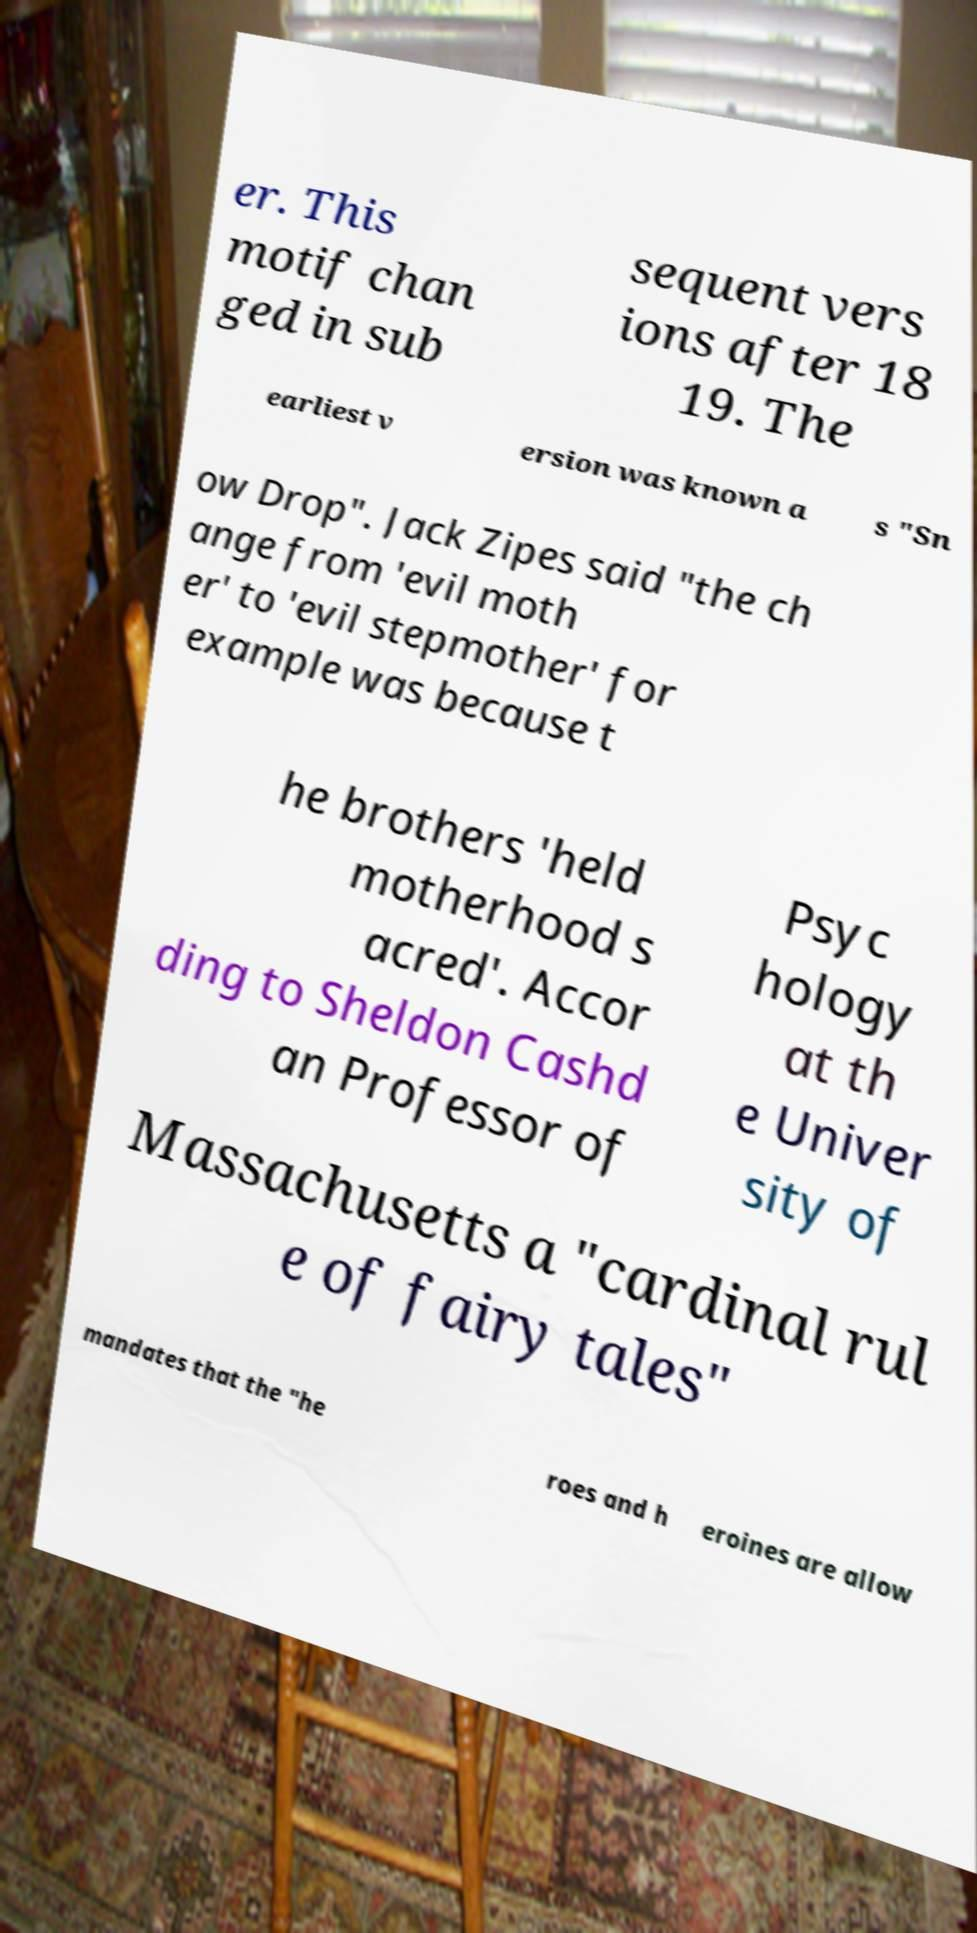I need the written content from this picture converted into text. Can you do that? er. This motif chan ged in sub sequent vers ions after 18 19. The earliest v ersion was known a s "Sn ow Drop". Jack Zipes said "the ch ange from 'evil moth er' to 'evil stepmother' for example was because t he brothers 'held motherhood s acred'. Accor ding to Sheldon Cashd an Professor of Psyc hology at th e Univer sity of Massachusetts a "cardinal rul e of fairy tales" mandates that the "he roes and h eroines are allow 